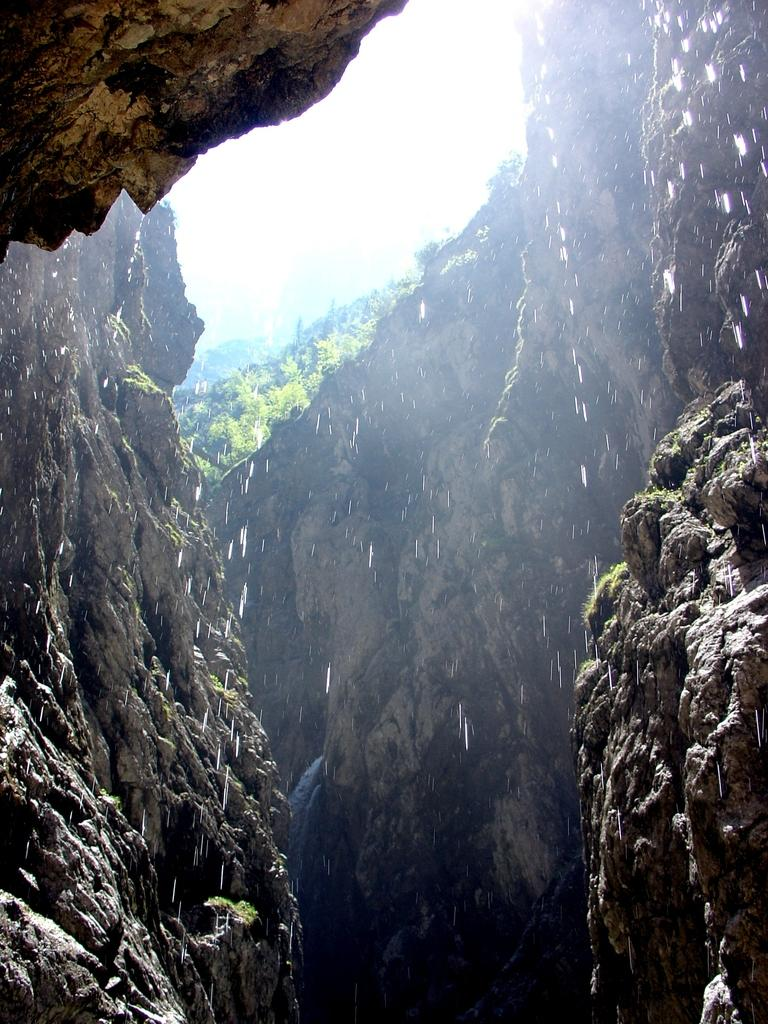What is the main subject of the image? There is a rock in the image. What can be seen in the background of the image? There are plants in the background of the image. What is the color of the plants in the image? The plants are green. What is visible above the plants in the image? The sky is visible in the image. What is the color of the sky in the image? The sky is white in color. How many cans are visible in the image? There are no cans present in the image. Can you see any snails crawling on the rock in the image? There are no snails visible in the image. 